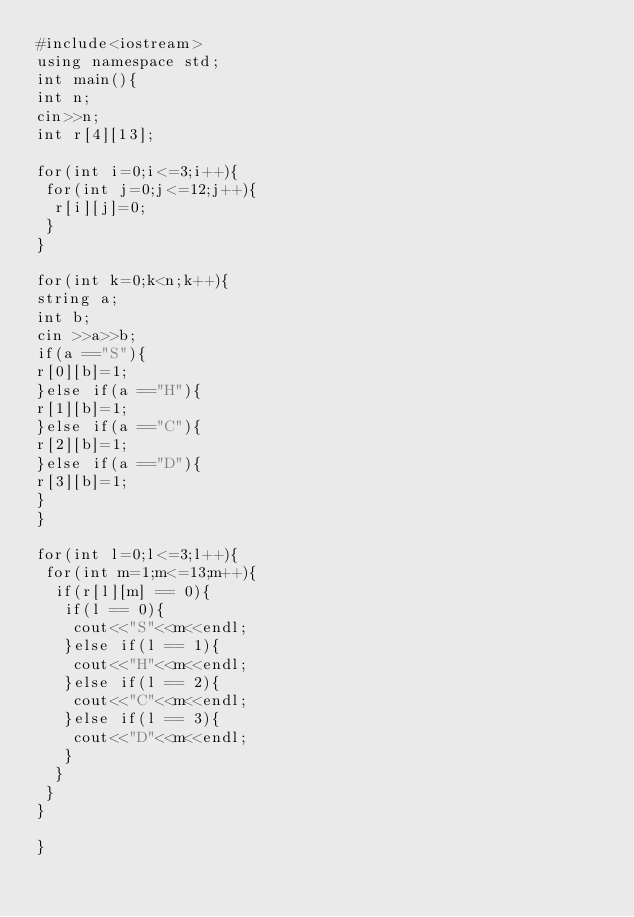Convert code to text. <code><loc_0><loc_0><loc_500><loc_500><_C++_>#include<iostream>
using namespace std;
int main(){
int n;
cin>>n;
int r[4][13];

for(int i=0;i<=3;i++){
 for(int j=0;j<=12;j++){
  r[i][j]=0;
 }
}

for(int k=0;k<n;k++){
string a;
int b;
cin >>a>>b;
if(a =="S"){
r[0][b]=1;
}else if(a =="H"){
r[1][b]=1;
}else if(a =="C"){
r[2][b]=1;
}else if(a =="D"){
r[3][b]=1;
}
}

for(int l=0;l<=3;l++){
 for(int m=1;m<=13;m++){
  if(r[l][m] == 0){
   if(l == 0){
    cout<<"S"<<m<<endl;
   }else if(l == 1){
    cout<<"H"<<m<<endl;
   }else if(l == 2){
    cout<<"C"<<m<<endl;
   }else if(l == 3){
    cout<<"D"<<m<<endl;
   }
  }
 }
}

}

</code> 